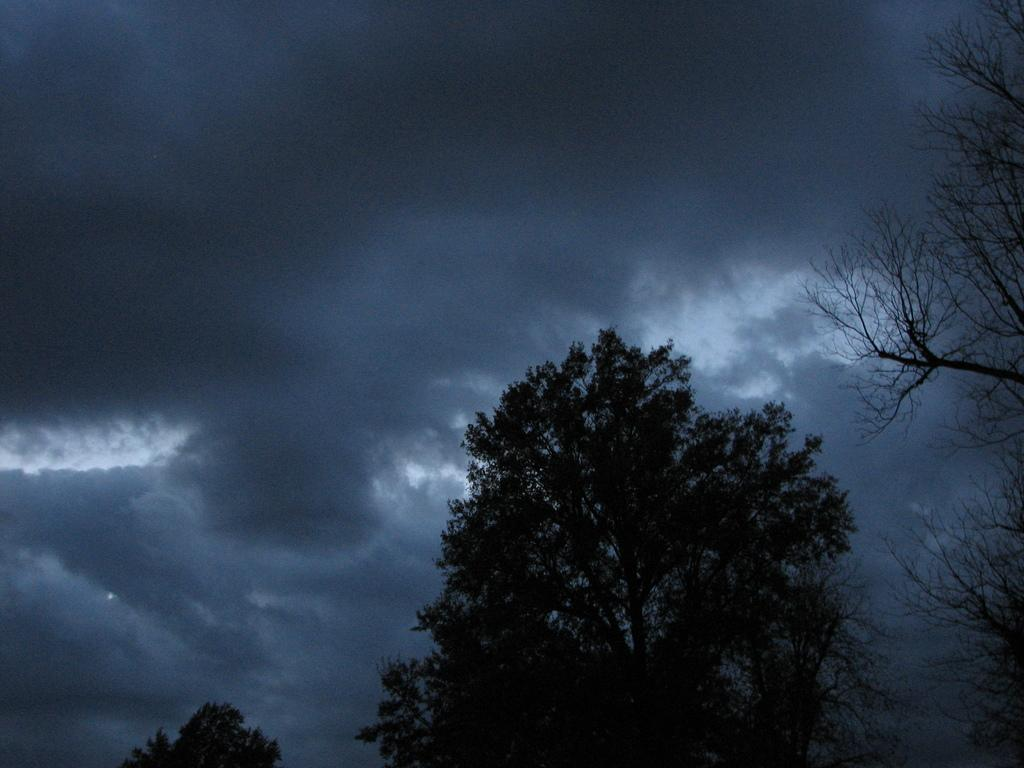What is located in the center of the image? There are trees in the center of the image. What can be seen in the sky in the background of the image? There are clouds in the sky in the background of the image. What type of offer is the dad making to the lizards in the image? There are no lizards or dad present in the image, so it is not possible to answer that question. 